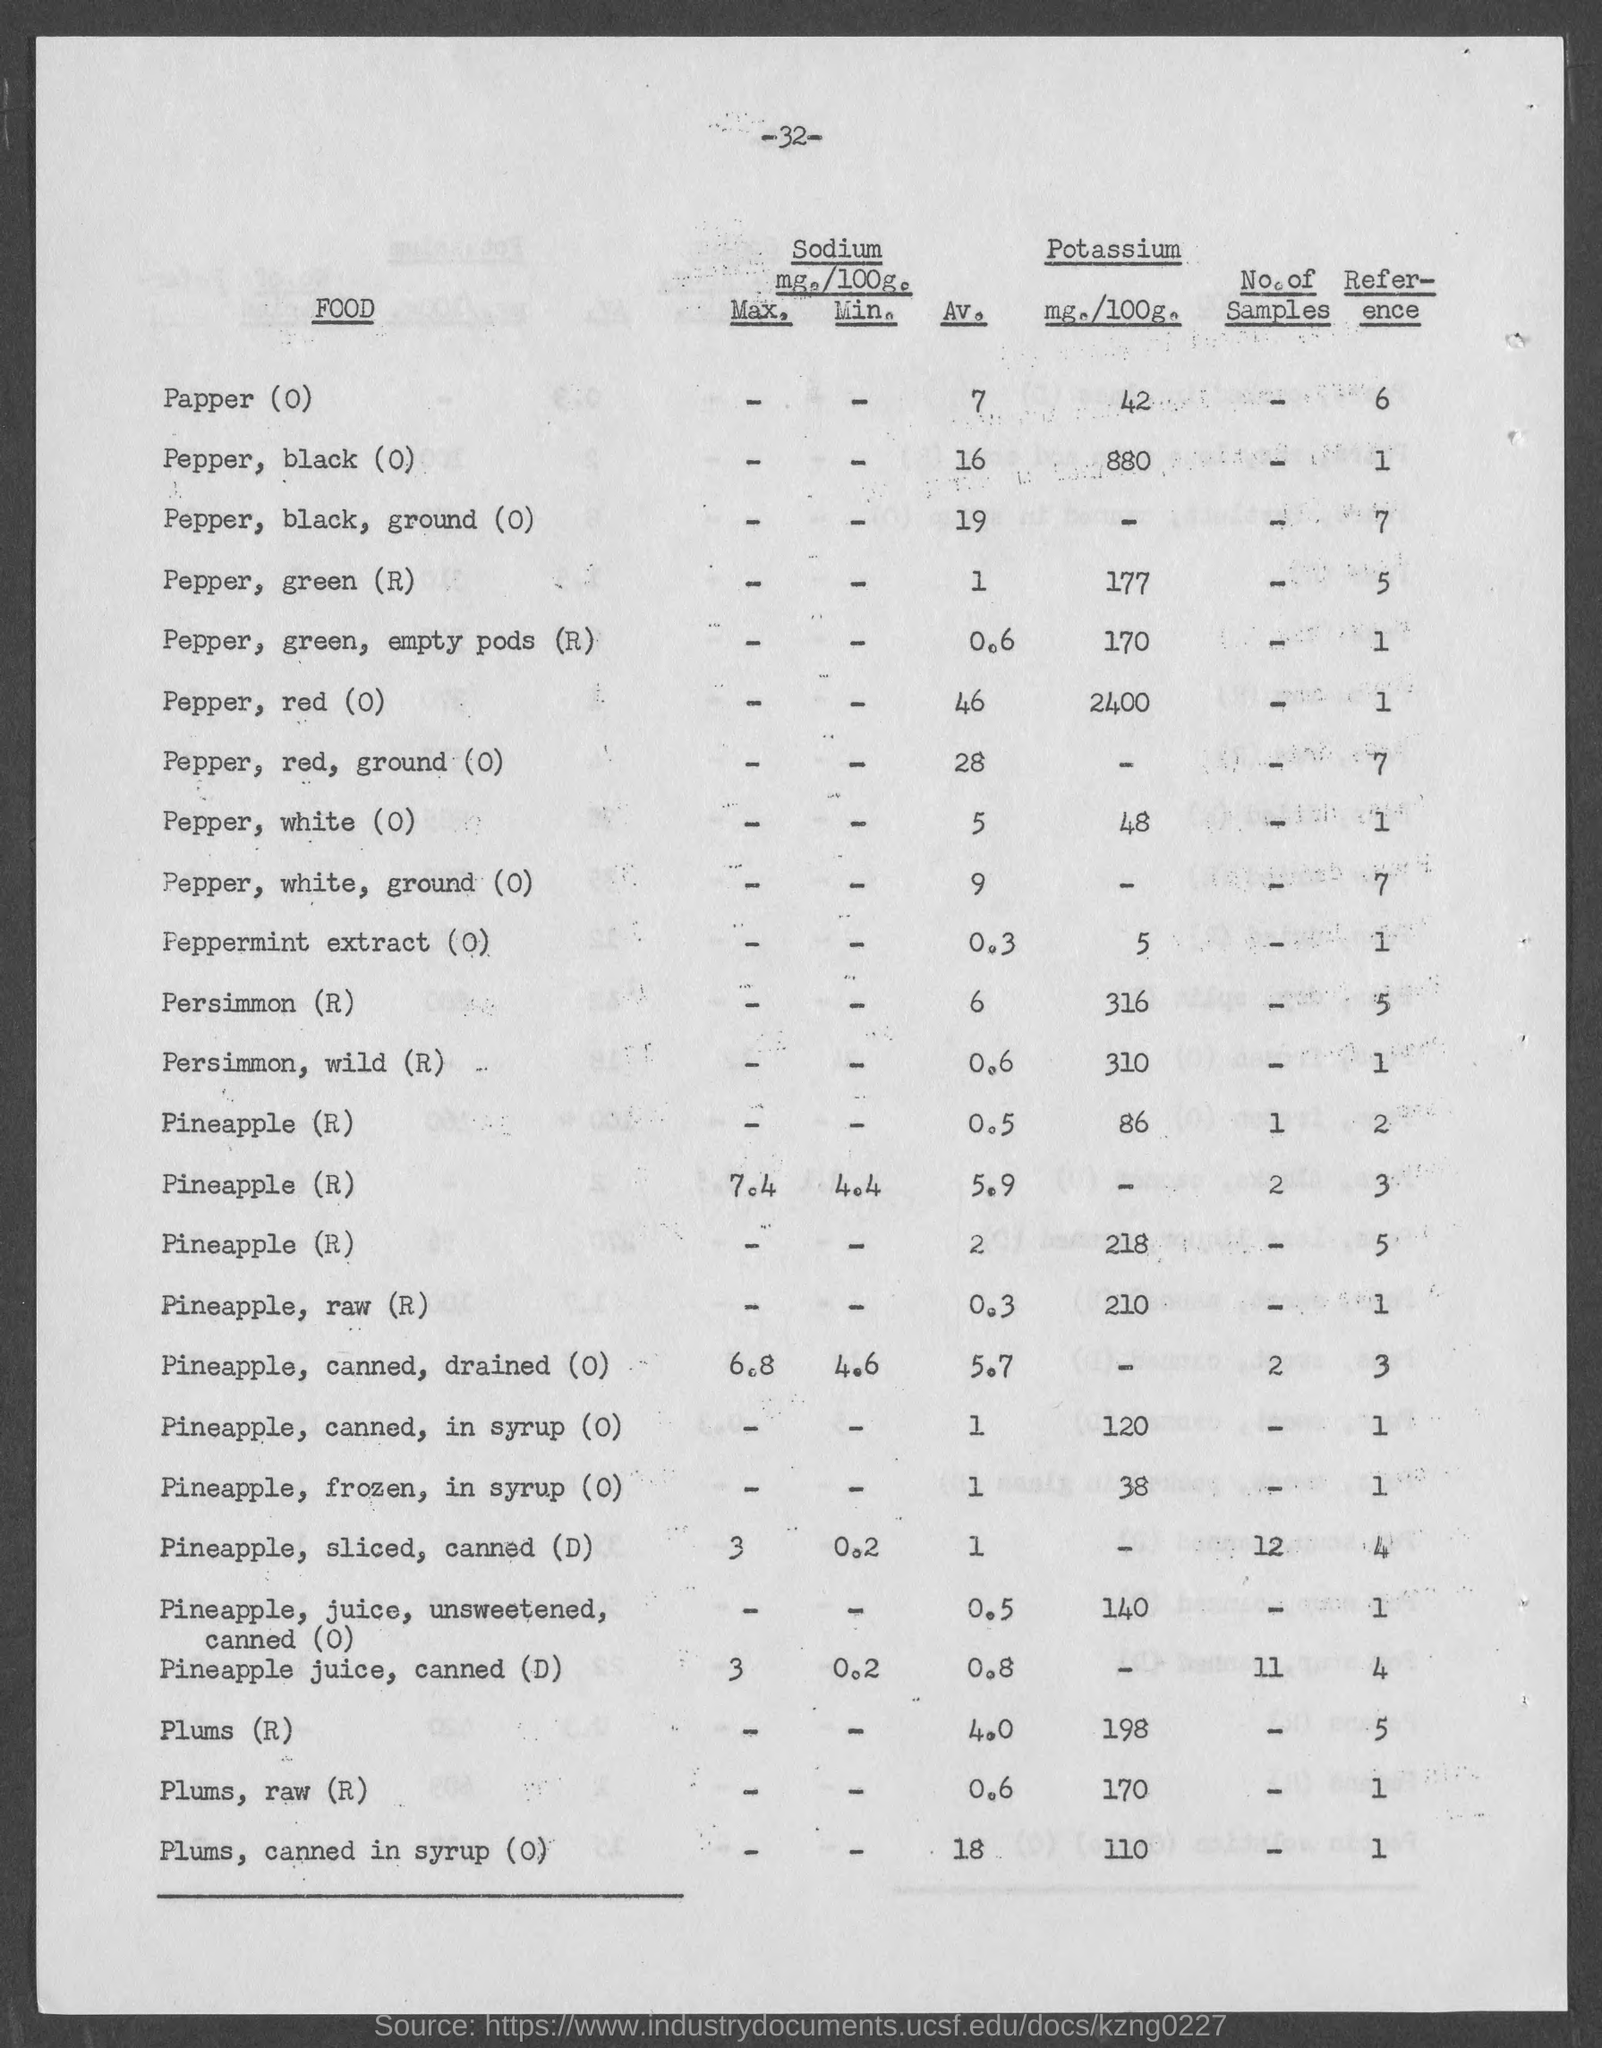Specify some key components in this picture. The raw pineapple contains 210 milligrams of potassium per 100 grams of weight. The amount of Potassium present in raw Plums is 170 milligrams per 100 grams. The average amount of sodium (mg./100g.) in red pepper is not available in the given data. The amount of potassium (in milligrams per 100 grams) present in black pepper is 880. The page number mentioned in this document is -32-. 